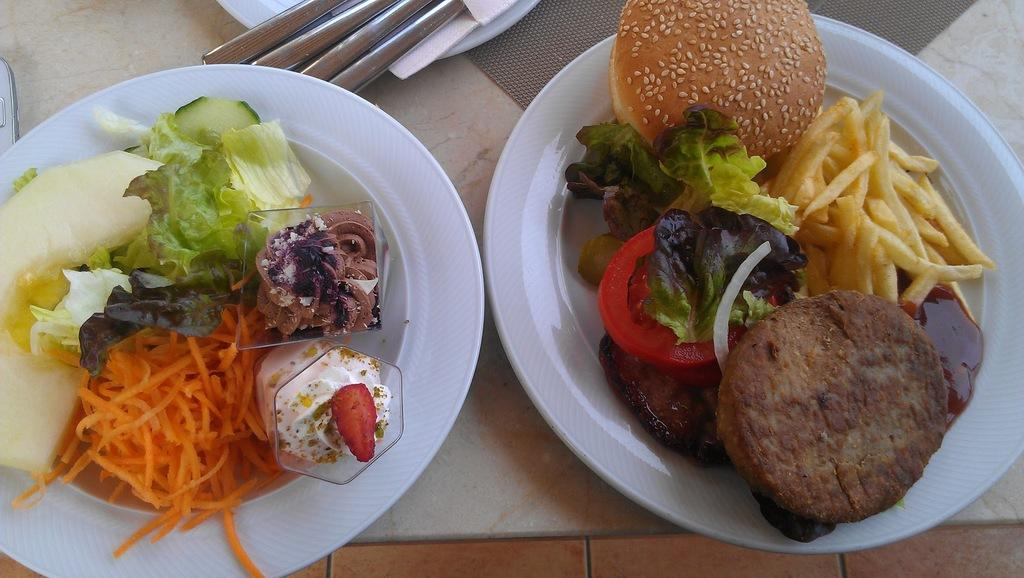What can be seen on the plates in the image? There are food items on plates in the image. Where are the food items located in relation to the image? The food items are in the foreground area of the image. What utensils are visible in the image? Spoons are visible in the image. Where are the spoons located in the image? The spoons are at the top side of the image. Can you tell me how many horses are present in the image? There are no horses present in the image; it features food items on plates and spoons. What type of wire is being used by the grandfather in the image? There is no grandfather or wire present in the image. 